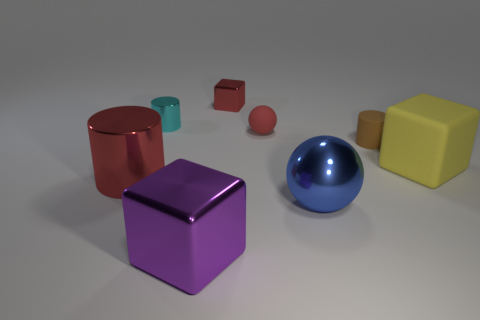Add 2 small brown cylinders. How many objects exist? 10 Subtract all cylinders. How many objects are left? 5 Add 4 tiny red things. How many tiny red things are left? 6 Add 4 large blue things. How many large blue things exist? 5 Subtract 1 red balls. How many objects are left? 7 Subtract all cylinders. Subtract all big green metal balls. How many objects are left? 5 